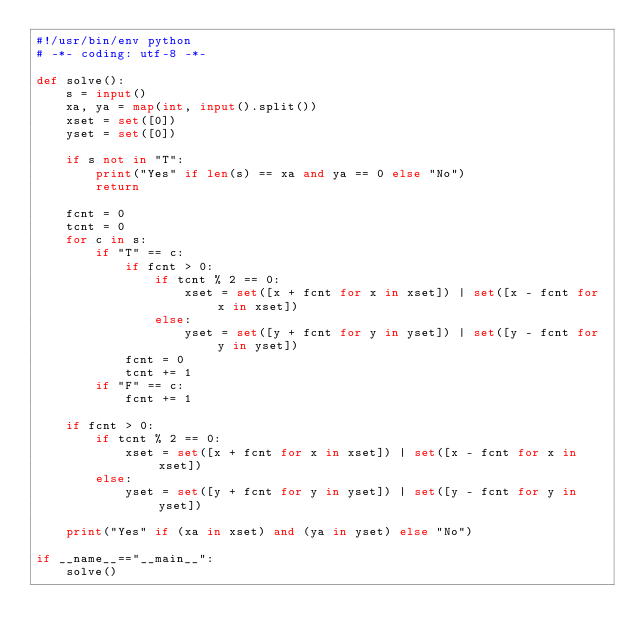<code> <loc_0><loc_0><loc_500><loc_500><_Python_>#!/usr/bin/env python
# -*- coding: utf-8 -*-

def solve():
    s = input()
    xa, ya = map(int, input().split())
    xset = set([0])
    yset = set([0])

    if s not in "T":
        print("Yes" if len(s) == xa and ya == 0 else "No")
        return

    fcnt = 0
    tcnt = 0
    for c in s:
        if "T" == c:
            if fcnt > 0:
                if tcnt % 2 == 0:
                    xset = set([x + fcnt for x in xset]) | set([x - fcnt for x in xset])
                else:
                    yset = set([y + fcnt for y in yset]) | set([y - fcnt for y in yset])
            fcnt = 0
            tcnt += 1
        if "F" == c:
            fcnt += 1

    if fcnt > 0:
        if tcnt % 2 == 0:
            xset = set([x + fcnt for x in xset]) | set([x - fcnt for x in xset])
        else:
            yset = set([y + fcnt for y in yset]) | set([y - fcnt for y in yset])
    
    print("Yes" if (xa in xset) and (ya in yset) else "No")

if __name__=="__main__":
    solve()
</code> 